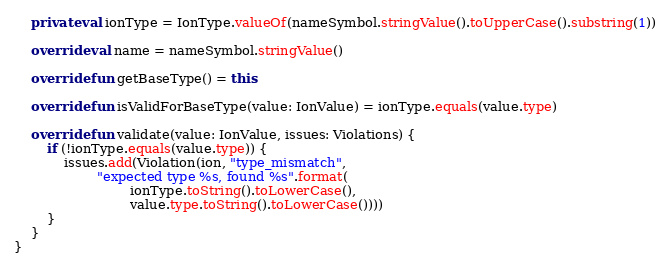<code> <loc_0><loc_0><loc_500><loc_500><_Kotlin_>
    private val ionType = IonType.valueOf(nameSymbol.stringValue().toUpperCase().substring(1))

    override val name = nameSymbol.stringValue()

    override fun getBaseType() = this

    override fun isValidForBaseType(value: IonValue) = ionType.equals(value.type)

    override fun validate(value: IonValue, issues: Violations) {
        if (!ionType.equals(value.type)) {
            issues.add(Violation(ion, "type_mismatch",
                    "expected type %s, found %s".format(
                            ionType.toString().toLowerCase(),
                            value.type.toString().toLowerCase())))
        }
    }
}
</code> 